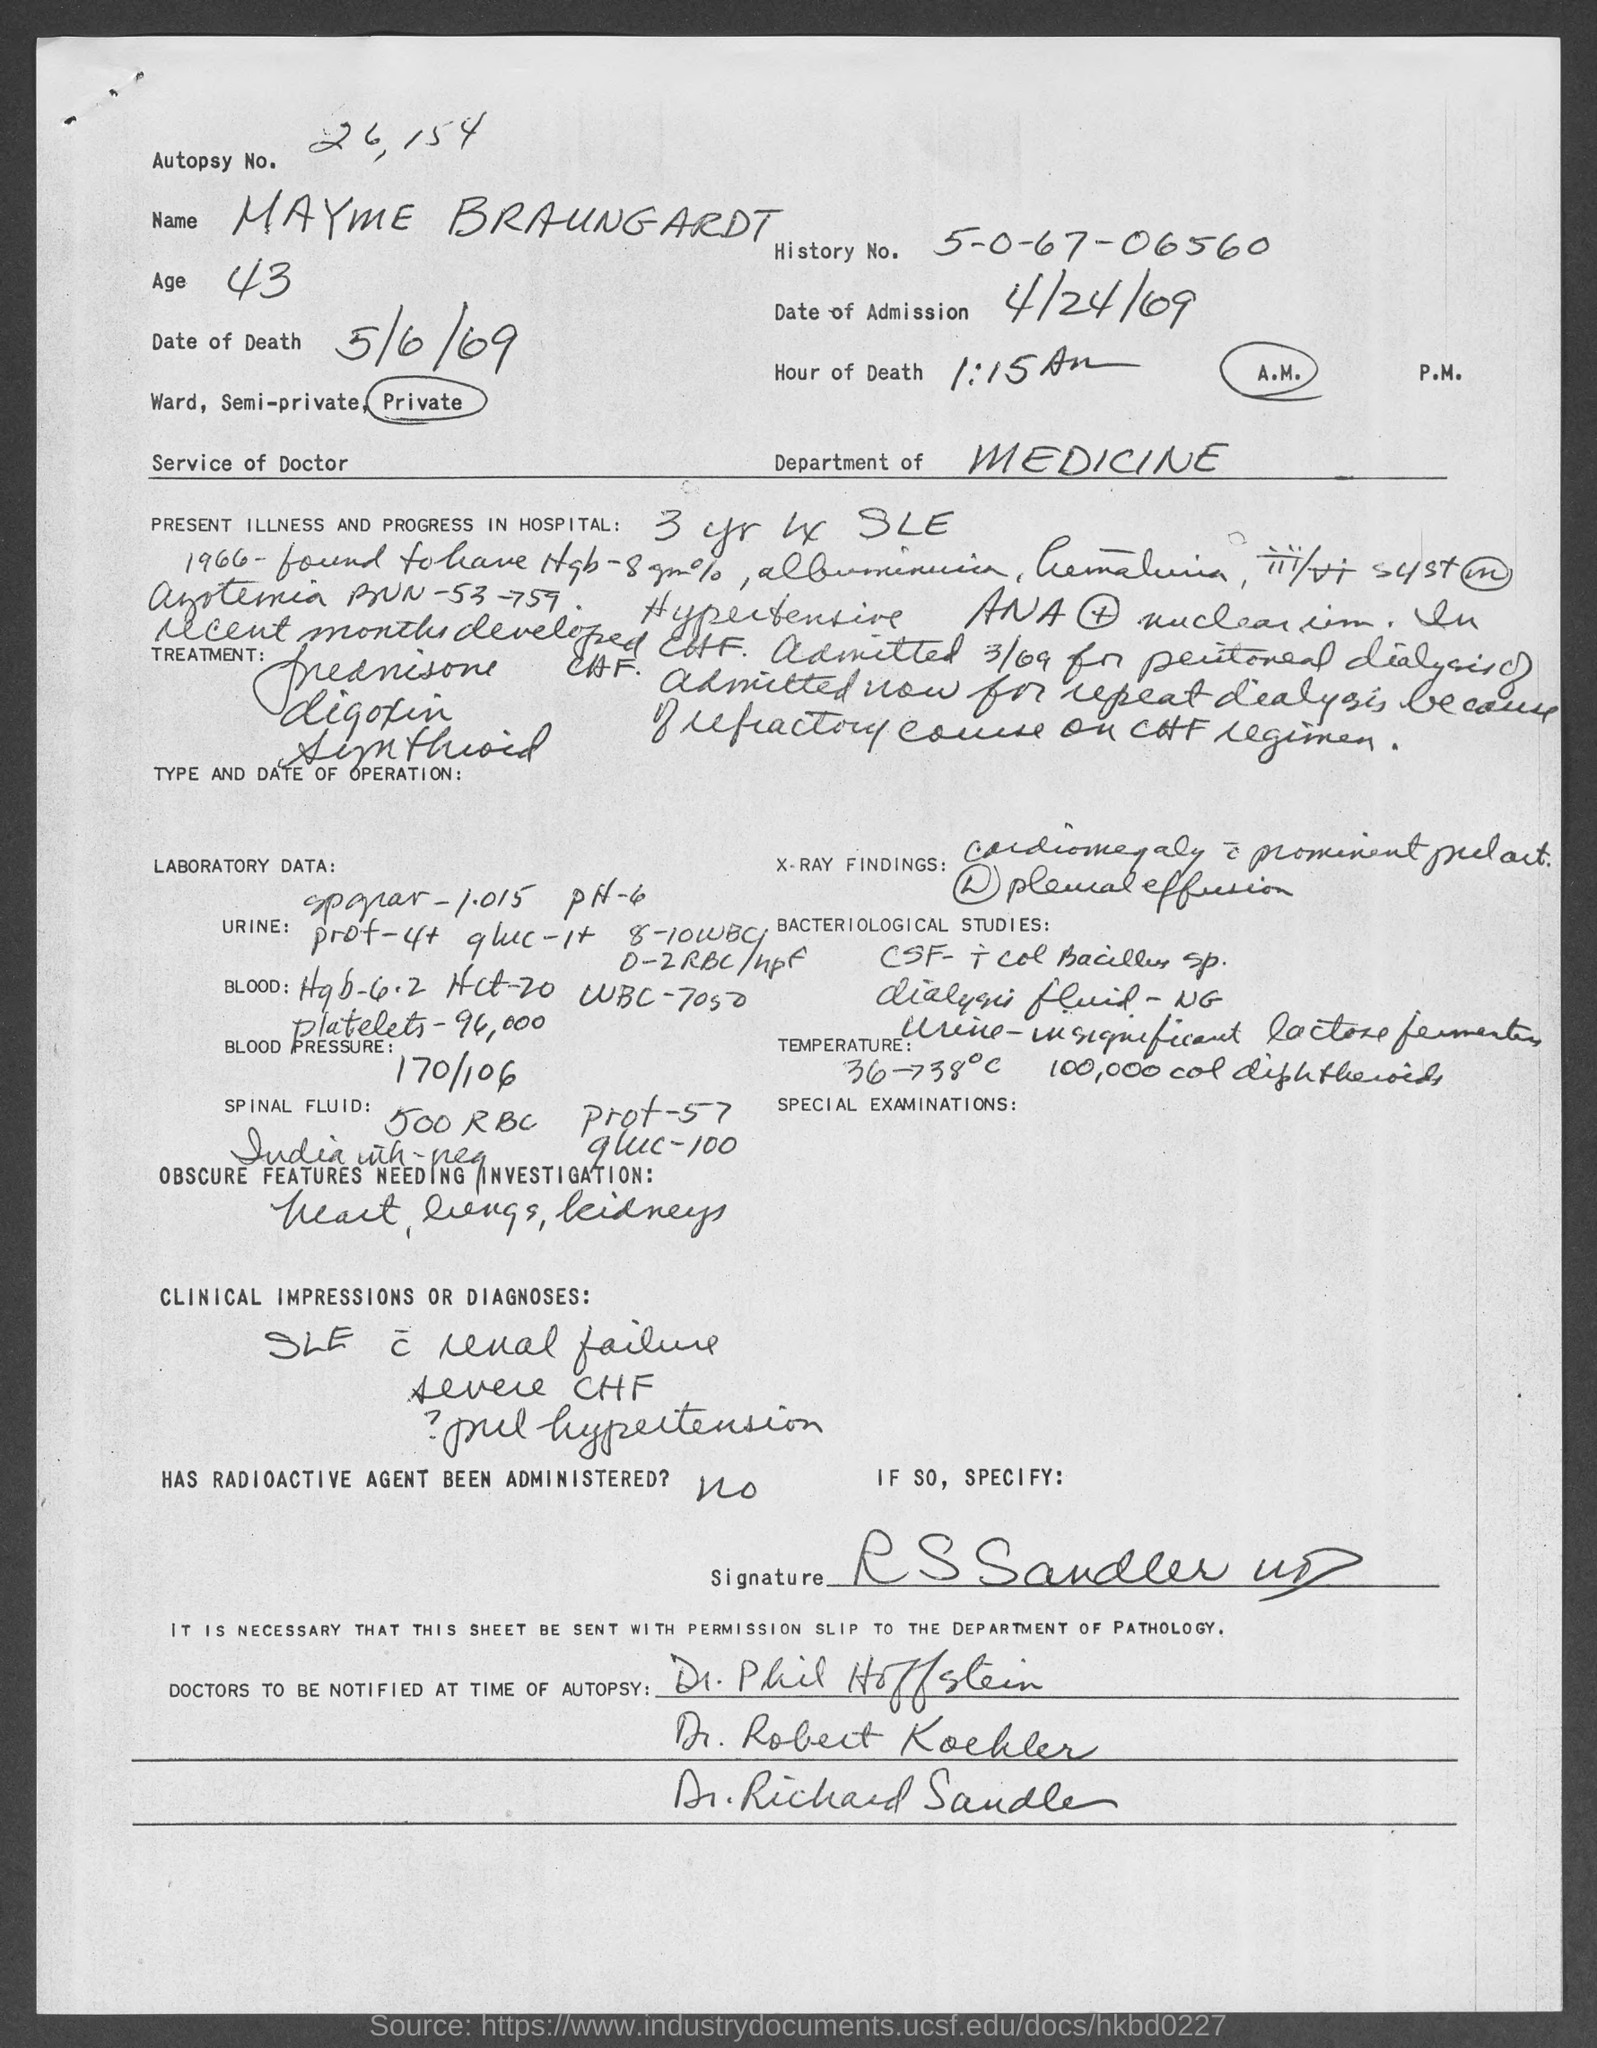What is the history no. ?
Your answer should be compact. 5-0-67-06560. What is the date of admission ?
Offer a very short reply. 4/24/69. What is the hour of death?
Make the answer very short. 1:15 A.M. What is date of death ?
Ensure brevity in your answer.  5/6/69. What is the name mentioned in top of the document ?
Provide a short and direct response. Mayme Braungardt. What is the age of mayme braungardt ?
Offer a very short reply. 43. 